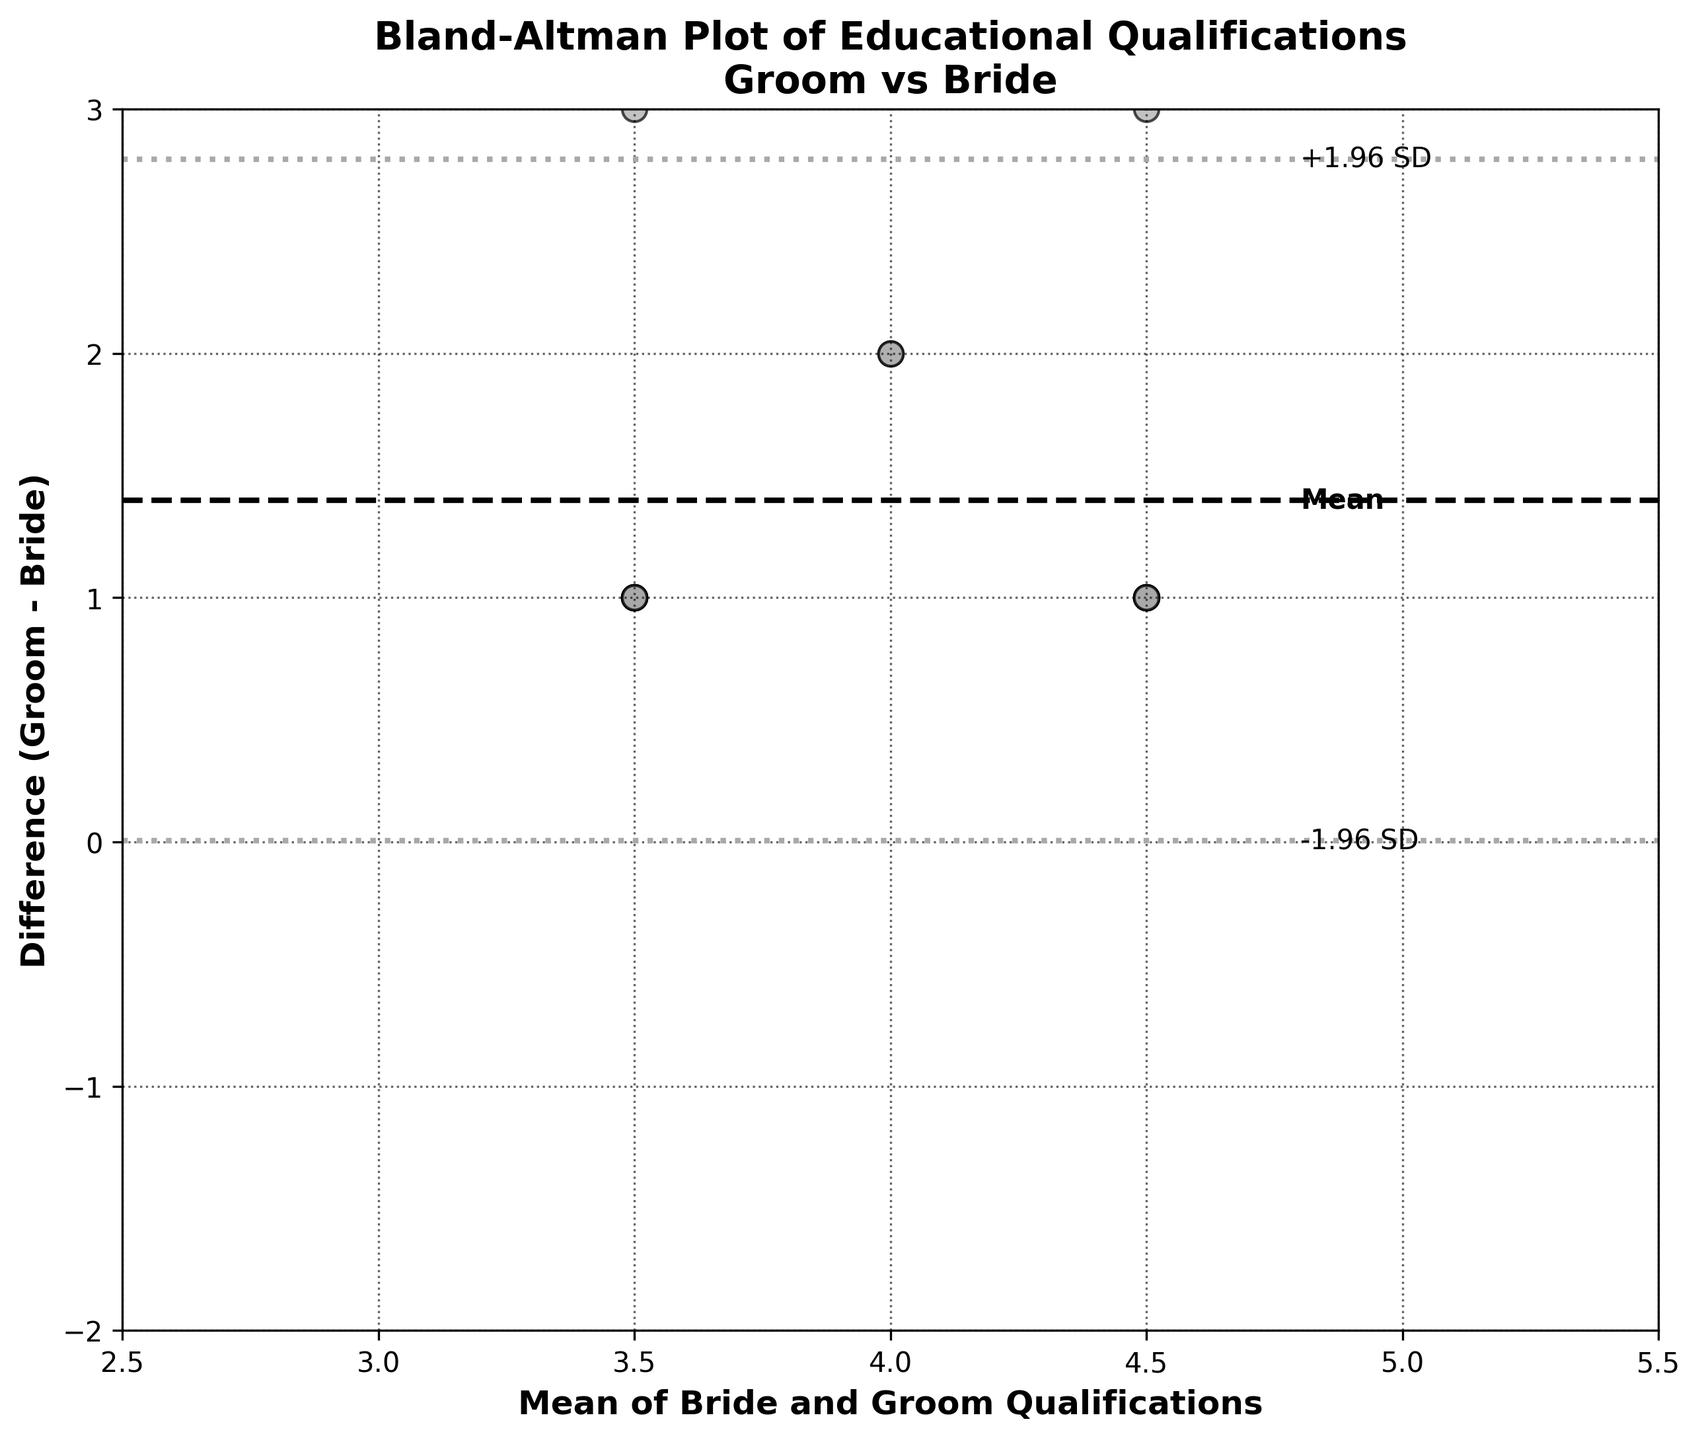What's the main title of the plot? The main title is usually placed at the top of the figure and describes the overall topic of the plot.
Answer: Bland-Altman Plot of Educational Qualifications Groom vs Bride What do the x-axis and y-axis represent? The axes are labeled to show what each dimension of the plot represents. The x-axis label is "Mean of Bride and Groom Qualifications," and the y-axis label is "Difference (Groom - Bride)."
Answer: Mean of Bride and Groom Qualifications (x-axis), Difference (Groom - Bride) (y-axis) How many data points are plotted in the figure? Each dot represents a pair of educational qualifications, so counting the dots gives the number of data points.
Answer: 15 What is the range of the x-axis values? The limits of the x-axis are given by the labels on the axis. The range starts from 2.5 to 5.5.
Answer: 2.5 to 5.5 What are the limits of agreement in the y-axis? The limits of agreement are indicated by the horizontal dotted lines. These lines are placed at mean_diff ± 1.96 * std_diff. One is around -1.1, and the other is around 2.1.
Answer: -1.1 and 2.1 What is the mean difference in qualifications between grooms and brides? The mean difference line is represented by a horizontal dashed line which is also labeled "Mean" in the plot. This line is at the value of approximately 0.6.
Answer: 0.6 Which data point has the highest average qualification? The average qualification is represented by the x-axis values, and the data point with the maximum x-coordinate represents the highest average qualification. The highest value is around 5.5.
Answer: 5.5 How many data points fall outside the limits of agreement? Points falling outside the horizontal dotted lines represent those beyond the limits of agreement. By visually counting these points, we find none of the points outside these lines.
Answer: 0 Is the mean difference positive or negative? The mean difference line is above zero on the y-axis, indicating a positive mean difference.
Answer: Positive What does a point below the mean difference line signify? A point below the mean difference line represents a scenario where the groom's qualification is less than the bride's qualification.
Answer: Groom's qualification is less than Bride's qualification 